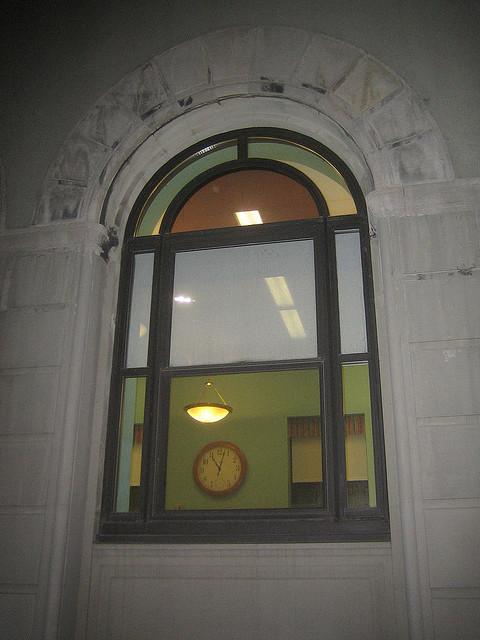What shape is the window?
Be succinct. Square. How many windows are shown?
Write a very short answer. 1. Was this picture taken after the invention of electricity?
Answer briefly. Yes. Is this a good view?
Quick response, please. No. What is shining through the window?
Give a very brief answer. Light. What time is on the clock?
Keep it brief. 11:03. What type of architecture is pictured?
Quick response, please. Arch. Are there designs in the stained glass?
Be succinct. No. 